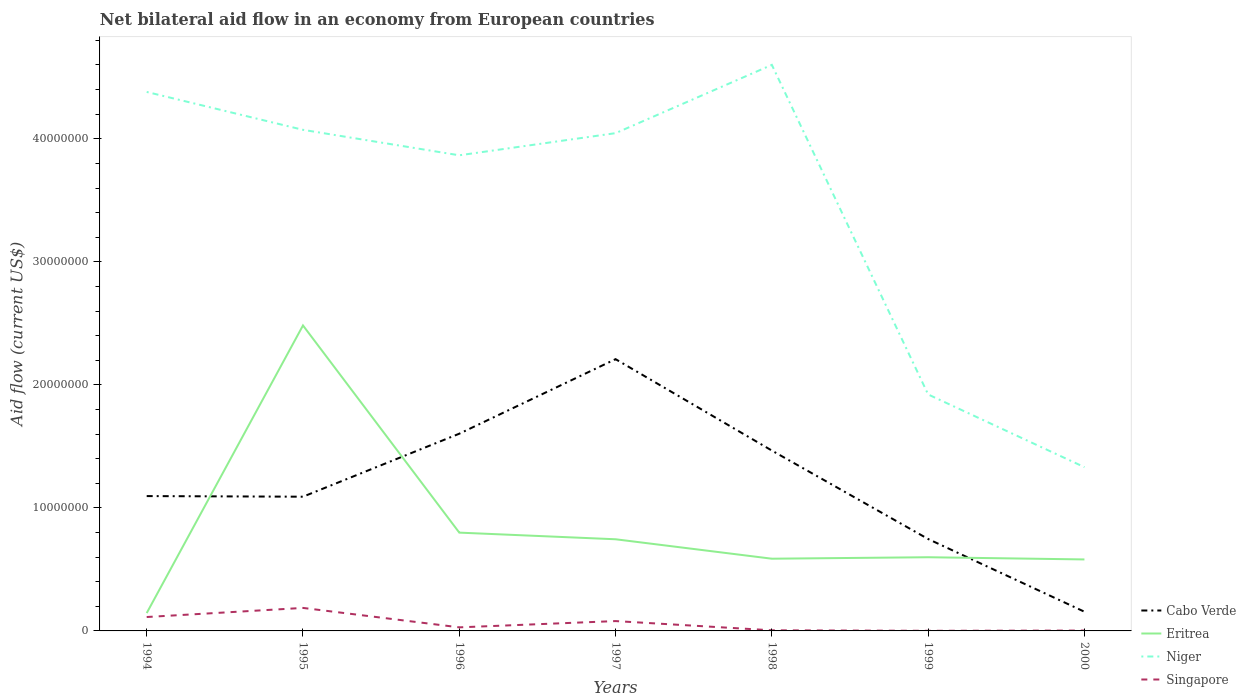Is the number of lines equal to the number of legend labels?
Offer a very short reply. Yes. Across all years, what is the maximum net bilateral aid flow in Eritrea?
Make the answer very short. 1.45e+06. What is the total net bilateral aid flow in Niger in the graph?
Give a very brief answer. 3.05e+07. What is the difference between the highest and the second highest net bilateral aid flow in Niger?
Give a very brief answer. 3.27e+07. How many lines are there?
Keep it short and to the point. 4. Are the values on the major ticks of Y-axis written in scientific E-notation?
Your answer should be compact. No. Does the graph contain any zero values?
Ensure brevity in your answer.  No. Where does the legend appear in the graph?
Make the answer very short. Bottom right. What is the title of the graph?
Provide a succinct answer. Net bilateral aid flow in an economy from European countries. Does "Marshall Islands" appear as one of the legend labels in the graph?
Offer a very short reply. No. What is the label or title of the X-axis?
Your response must be concise. Years. What is the label or title of the Y-axis?
Your answer should be compact. Aid flow (current US$). What is the Aid flow (current US$) of Cabo Verde in 1994?
Provide a short and direct response. 1.10e+07. What is the Aid flow (current US$) of Eritrea in 1994?
Your response must be concise. 1.45e+06. What is the Aid flow (current US$) in Niger in 1994?
Provide a short and direct response. 4.38e+07. What is the Aid flow (current US$) of Singapore in 1994?
Provide a short and direct response. 1.13e+06. What is the Aid flow (current US$) of Cabo Verde in 1995?
Ensure brevity in your answer.  1.09e+07. What is the Aid flow (current US$) of Eritrea in 1995?
Offer a very short reply. 2.48e+07. What is the Aid flow (current US$) in Niger in 1995?
Offer a very short reply. 4.07e+07. What is the Aid flow (current US$) of Singapore in 1995?
Your response must be concise. 1.87e+06. What is the Aid flow (current US$) of Cabo Verde in 1996?
Your answer should be compact. 1.60e+07. What is the Aid flow (current US$) of Eritrea in 1996?
Provide a succinct answer. 7.99e+06. What is the Aid flow (current US$) in Niger in 1996?
Ensure brevity in your answer.  3.87e+07. What is the Aid flow (current US$) in Cabo Verde in 1997?
Your answer should be very brief. 2.21e+07. What is the Aid flow (current US$) in Eritrea in 1997?
Provide a succinct answer. 7.45e+06. What is the Aid flow (current US$) of Niger in 1997?
Offer a terse response. 4.05e+07. What is the Aid flow (current US$) in Cabo Verde in 1998?
Provide a succinct answer. 1.47e+07. What is the Aid flow (current US$) in Eritrea in 1998?
Offer a very short reply. 5.87e+06. What is the Aid flow (current US$) of Niger in 1998?
Provide a short and direct response. 4.60e+07. What is the Aid flow (current US$) in Singapore in 1998?
Give a very brief answer. 5.00e+04. What is the Aid flow (current US$) of Cabo Verde in 1999?
Provide a short and direct response. 7.47e+06. What is the Aid flow (current US$) in Eritrea in 1999?
Ensure brevity in your answer.  5.99e+06. What is the Aid flow (current US$) in Niger in 1999?
Provide a short and direct response. 1.92e+07. What is the Aid flow (current US$) in Cabo Verde in 2000?
Give a very brief answer. 1.56e+06. What is the Aid flow (current US$) of Eritrea in 2000?
Your answer should be compact. 5.81e+06. What is the Aid flow (current US$) in Niger in 2000?
Offer a terse response. 1.33e+07. What is the Aid flow (current US$) of Singapore in 2000?
Ensure brevity in your answer.  3.00e+04. Across all years, what is the maximum Aid flow (current US$) in Cabo Verde?
Offer a terse response. 2.21e+07. Across all years, what is the maximum Aid flow (current US$) of Eritrea?
Your answer should be very brief. 2.48e+07. Across all years, what is the maximum Aid flow (current US$) in Niger?
Your response must be concise. 4.60e+07. Across all years, what is the maximum Aid flow (current US$) in Singapore?
Offer a terse response. 1.87e+06. Across all years, what is the minimum Aid flow (current US$) of Cabo Verde?
Your response must be concise. 1.56e+06. Across all years, what is the minimum Aid flow (current US$) of Eritrea?
Make the answer very short. 1.45e+06. Across all years, what is the minimum Aid flow (current US$) of Niger?
Give a very brief answer. 1.33e+07. Across all years, what is the minimum Aid flow (current US$) of Singapore?
Your response must be concise. 10000. What is the total Aid flow (current US$) in Cabo Verde in the graph?
Your answer should be very brief. 8.37e+07. What is the total Aid flow (current US$) of Eritrea in the graph?
Offer a very short reply. 5.94e+07. What is the total Aid flow (current US$) of Niger in the graph?
Make the answer very short. 2.42e+08. What is the total Aid flow (current US$) of Singapore in the graph?
Give a very brief answer. 4.18e+06. What is the difference between the Aid flow (current US$) of Cabo Verde in 1994 and that in 1995?
Your answer should be very brief. 5.00e+04. What is the difference between the Aid flow (current US$) in Eritrea in 1994 and that in 1995?
Offer a very short reply. -2.34e+07. What is the difference between the Aid flow (current US$) of Niger in 1994 and that in 1995?
Ensure brevity in your answer.  3.08e+06. What is the difference between the Aid flow (current US$) in Singapore in 1994 and that in 1995?
Ensure brevity in your answer.  -7.40e+05. What is the difference between the Aid flow (current US$) of Cabo Verde in 1994 and that in 1996?
Your answer should be compact. -5.07e+06. What is the difference between the Aid flow (current US$) of Eritrea in 1994 and that in 1996?
Your answer should be very brief. -6.54e+06. What is the difference between the Aid flow (current US$) of Niger in 1994 and that in 1996?
Your answer should be very brief. 5.15e+06. What is the difference between the Aid flow (current US$) in Singapore in 1994 and that in 1996?
Provide a short and direct response. 8.40e+05. What is the difference between the Aid flow (current US$) in Cabo Verde in 1994 and that in 1997?
Make the answer very short. -1.11e+07. What is the difference between the Aid flow (current US$) of Eritrea in 1994 and that in 1997?
Your response must be concise. -6.00e+06. What is the difference between the Aid flow (current US$) in Niger in 1994 and that in 1997?
Provide a succinct answer. 3.35e+06. What is the difference between the Aid flow (current US$) in Cabo Verde in 1994 and that in 1998?
Your answer should be compact. -3.70e+06. What is the difference between the Aid flow (current US$) in Eritrea in 1994 and that in 1998?
Offer a terse response. -4.42e+06. What is the difference between the Aid flow (current US$) in Niger in 1994 and that in 1998?
Your answer should be compact. -2.20e+06. What is the difference between the Aid flow (current US$) of Singapore in 1994 and that in 1998?
Offer a terse response. 1.08e+06. What is the difference between the Aid flow (current US$) of Cabo Verde in 1994 and that in 1999?
Offer a very short reply. 3.49e+06. What is the difference between the Aid flow (current US$) in Eritrea in 1994 and that in 1999?
Make the answer very short. -4.54e+06. What is the difference between the Aid flow (current US$) of Niger in 1994 and that in 1999?
Ensure brevity in your answer.  2.46e+07. What is the difference between the Aid flow (current US$) of Singapore in 1994 and that in 1999?
Give a very brief answer. 1.12e+06. What is the difference between the Aid flow (current US$) of Cabo Verde in 1994 and that in 2000?
Your answer should be very brief. 9.40e+06. What is the difference between the Aid flow (current US$) in Eritrea in 1994 and that in 2000?
Make the answer very short. -4.36e+06. What is the difference between the Aid flow (current US$) of Niger in 1994 and that in 2000?
Your answer should be compact. 3.05e+07. What is the difference between the Aid flow (current US$) in Singapore in 1994 and that in 2000?
Your answer should be very brief. 1.10e+06. What is the difference between the Aid flow (current US$) of Cabo Verde in 1995 and that in 1996?
Offer a very short reply. -5.12e+06. What is the difference between the Aid flow (current US$) in Eritrea in 1995 and that in 1996?
Ensure brevity in your answer.  1.68e+07. What is the difference between the Aid flow (current US$) of Niger in 1995 and that in 1996?
Keep it short and to the point. 2.07e+06. What is the difference between the Aid flow (current US$) of Singapore in 1995 and that in 1996?
Offer a terse response. 1.58e+06. What is the difference between the Aid flow (current US$) in Cabo Verde in 1995 and that in 1997?
Offer a very short reply. -1.12e+07. What is the difference between the Aid flow (current US$) of Eritrea in 1995 and that in 1997?
Offer a very short reply. 1.74e+07. What is the difference between the Aid flow (current US$) in Singapore in 1995 and that in 1997?
Offer a terse response. 1.07e+06. What is the difference between the Aid flow (current US$) of Cabo Verde in 1995 and that in 1998?
Offer a terse response. -3.75e+06. What is the difference between the Aid flow (current US$) in Eritrea in 1995 and that in 1998?
Keep it short and to the point. 1.90e+07. What is the difference between the Aid flow (current US$) of Niger in 1995 and that in 1998?
Offer a very short reply. -5.28e+06. What is the difference between the Aid flow (current US$) of Singapore in 1995 and that in 1998?
Keep it short and to the point. 1.82e+06. What is the difference between the Aid flow (current US$) in Cabo Verde in 1995 and that in 1999?
Offer a terse response. 3.44e+06. What is the difference between the Aid flow (current US$) of Eritrea in 1995 and that in 1999?
Make the answer very short. 1.88e+07. What is the difference between the Aid flow (current US$) of Niger in 1995 and that in 1999?
Your response must be concise. 2.15e+07. What is the difference between the Aid flow (current US$) of Singapore in 1995 and that in 1999?
Make the answer very short. 1.86e+06. What is the difference between the Aid flow (current US$) in Cabo Verde in 1995 and that in 2000?
Provide a short and direct response. 9.35e+06. What is the difference between the Aid flow (current US$) in Eritrea in 1995 and that in 2000?
Provide a short and direct response. 1.90e+07. What is the difference between the Aid flow (current US$) in Niger in 1995 and that in 2000?
Your response must be concise. 2.74e+07. What is the difference between the Aid flow (current US$) in Singapore in 1995 and that in 2000?
Provide a short and direct response. 1.84e+06. What is the difference between the Aid flow (current US$) in Cabo Verde in 1996 and that in 1997?
Your answer should be compact. -6.06e+06. What is the difference between the Aid flow (current US$) in Eritrea in 1996 and that in 1997?
Make the answer very short. 5.40e+05. What is the difference between the Aid flow (current US$) of Niger in 1996 and that in 1997?
Your answer should be compact. -1.80e+06. What is the difference between the Aid flow (current US$) of Singapore in 1996 and that in 1997?
Your answer should be compact. -5.10e+05. What is the difference between the Aid flow (current US$) in Cabo Verde in 1996 and that in 1998?
Keep it short and to the point. 1.37e+06. What is the difference between the Aid flow (current US$) in Eritrea in 1996 and that in 1998?
Keep it short and to the point. 2.12e+06. What is the difference between the Aid flow (current US$) in Niger in 1996 and that in 1998?
Give a very brief answer. -7.35e+06. What is the difference between the Aid flow (current US$) in Cabo Verde in 1996 and that in 1999?
Keep it short and to the point. 8.56e+06. What is the difference between the Aid flow (current US$) of Niger in 1996 and that in 1999?
Keep it short and to the point. 1.94e+07. What is the difference between the Aid flow (current US$) of Cabo Verde in 1996 and that in 2000?
Ensure brevity in your answer.  1.45e+07. What is the difference between the Aid flow (current US$) of Eritrea in 1996 and that in 2000?
Provide a short and direct response. 2.18e+06. What is the difference between the Aid flow (current US$) of Niger in 1996 and that in 2000?
Your response must be concise. 2.54e+07. What is the difference between the Aid flow (current US$) of Cabo Verde in 1997 and that in 1998?
Provide a short and direct response. 7.43e+06. What is the difference between the Aid flow (current US$) in Eritrea in 1997 and that in 1998?
Provide a short and direct response. 1.58e+06. What is the difference between the Aid flow (current US$) in Niger in 1997 and that in 1998?
Provide a succinct answer. -5.55e+06. What is the difference between the Aid flow (current US$) in Singapore in 1997 and that in 1998?
Your response must be concise. 7.50e+05. What is the difference between the Aid flow (current US$) in Cabo Verde in 1997 and that in 1999?
Keep it short and to the point. 1.46e+07. What is the difference between the Aid flow (current US$) of Eritrea in 1997 and that in 1999?
Provide a short and direct response. 1.46e+06. What is the difference between the Aid flow (current US$) of Niger in 1997 and that in 1999?
Ensure brevity in your answer.  2.12e+07. What is the difference between the Aid flow (current US$) of Singapore in 1997 and that in 1999?
Give a very brief answer. 7.90e+05. What is the difference between the Aid flow (current US$) of Cabo Verde in 1997 and that in 2000?
Your answer should be very brief. 2.05e+07. What is the difference between the Aid flow (current US$) in Eritrea in 1997 and that in 2000?
Keep it short and to the point. 1.64e+06. What is the difference between the Aid flow (current US$) in Niger in 1997 and that in 2000?
Keep it short and to the point. 2.72e+07. What is the difference between the Aid flow (current US$) of Singapore in 1997 and that in 2000?
Your response must be concise. 7.70e+05. What is the difference between the Aid flow (current US$) in Cabo Verde in 1998 and that in 1999?
Your response must be concise. 7.19e+06. What is the difference between the Aid flow (current US$) in Eritrea in 1998 and that in 1999?
Offer a terse response. -1.20e+05. What is the difference between the Aid flow (current US$) in Niger in 1998 and that in 1999?
Keep it short and to the point. 2.68e+07. What is the difference between the Aid flow (current US$) of Cabo Verde in 1998 and that in 2000?
Make the answer very short. 1.31e+07. What is the difference between the Aid flow (current US$) of Eritrea in 1998 and that in 2000?
Offer a terse response. 6.00e+04. What is the difference between the Aid flow (current US$) of Niger in 1998 and that in 2000?
Offer a very short reply. 3.27e+07. What is the difference between the Aid flow (current US$) in Cabo Verde in 1999 and that in 2000?
Provide a short and direct response. 5.91e+06. What is the difference between the Aid flow (current US$) of Eritrea in 1999 and that in 2000?
Keep it short and to the point. 1.80e+05. What is the difference between the Aid flow (current US$) of Niger in 1999 and that in 2000?
Your answer should be very brief. 5.91e+06. What is the difference between the Aid flow (current US$) of Cabo Verde in 1994 and the Aid flow (current US$) of Eritrea in 1995?
Your response must be concise. -1.39e+07. What is the difference between the Aid flow (current US$) of Cabo Verde in 1994 and the Aid flow (current US$) of Niger in 1995?
Give a very brief answer. -2.98e+07. What is the difference between the Aid flow (current US$) of Cabo Verde in 1994 and the Aid flow (current US$) of Singapore in 1995?
Keep it short and to the point. 9.09e+06. What is the difference between the Aid flow (current US$) in Eritrea in 1994 and the Aid flow (current US$) in Niger in 1995?
Offer a terse response. -3.93e+07. What is the difference between the Aid flow (current US$) in Eritrea in 1994 and the Aid flow (current US$) in Singapore in 1995?
Give a very brief answer. -4.20e+05. What is the difference between the Aid flow (current US$) in Niger in 1994 and the Aid flow (current US$) in Singapore in 1995?
Offer a terse response. 4.19e+07. What is the difference between the Aid flow (current US$) of Cabo Verde in 1994 and the Aid flow (current US$) of Eritrea in 1996?
Your response must be concise. 2.97e+06. What is the difference between the Aid flow (current US$) of Cabo Verde in 1994 and the Aid flow (current US$) of Niger in 1996?
Provide a succinct answer. -2.77e+07. What is the difference between the Aid flow (current US$) of Cabo Verde in 1994 and the Aid flow (current US$) of Singapore in 1996?
Your answer should be compact. 1.07e+07. What is the difference between the Aid flow (current US$) of Eritrea in 1994 and the Aid flow (current US$) of Niger in 1996?
Keep it short and to the point. -3.72e+07. What is the difference between the Aid flow (current US$) in Eritrea in 1994 and the Aid flow (current US$) in Singapore in 1996?
Provide a succinct answer. 1.16e+06. What is the difference between the Aid flow (current US$) in Niger in 1994 and the Aid flow (current US$) in Singapore in 1996?
Offer a very short reply. 4.35e+07. What is the difference between the Aid flow (current US$) of Cabo Verde in 1994 and the Aid flow (current US$) of Eritrea in 1997?
Your response must be concise. 3.51e+06. What is the difference between the Aid flow (current US$) of Cabo Verde in 1994 and the Aid flow (current US$) of Niger in 1997?
Your answer should be very brief. -2.95e+07. What is the difference between the Aid flow (current US$) in Cabo Verde in 1994 and the Aid flow (current US$) in Singapore in 1997?
Offer a terse response. 1.02e+07. What is the difference between the Aid flow (current US$) of Eritrea in 1994 and the Aid flow (current US$) of Niger in 1997?
Give a very brief answer. -3.90e+07. What is the difference between the Aid flow (current US$) of Eritrea in 1994 and the Aid flow (current US$) of Singapore in 1997?
Give a very brief answer. 6.50e+05. What is the difference between the Aid flow (current US$) of Niger in 1994 and the Aid flow (current US$) of Singapore in 1997?
Provide a succinct answer. 4.30e+07. What is the difference between the Aid flow (current US$) of Cabo Verde in 1994 and the Aid flow (current US$) of Eritrea in 1998?
Provide a succinct answer. 5.09e+06. What is the difference between the Aid flow (current US$) in Cabo Verde in 1994 and the Aid flow (current US$) in Niger in 1998?
Keep it short and to the point. -3.50e+07. What is the difference between the Aid flow (current US$) of Cabo Verde in 1994 and the Aid flow (current US$) of Singapore in 1998?
Offer a terse response. 1.09e+07. What is the difference between the Aid flow (current US$) of Eritrea in 1994 and the Aid flow (current US$) of Niger in 1998?
Your response must be concise. -4.46e+07. What is the difference between the Aid flow (current US$) in Eritrea in 1994 and the Aid flow (current US$) in Singapore in 1998?
Provide a short and direct response. 1.40e+06. What is the difference between the Aid flow (current US$) of Niger in 1994 and the Aid flow (current US$) of Singapore in 1998?
Make the answer very short. 4.38e+07. What is the difference between the Aid flow (current US$) in Cabo Verde in 1994 and the Aid flow (current US$) in Eritrea in 1999?
Offer a very short reply. 4.97e+06. What is the difference between the Aid flow (current US$) of Cabo Verde in 1994 and the Aid flow (current US$) of Niger in 1999?
Keep it short and to the point. -8.26e+06. What is the difference between the Aid flow (current US$) in Cabo Verde in 1994 and the Aid flow (current US$) in Singapore in 1999?
Offer a terse response. 1.10e+07. What is the difference between the Aid flow (current US$) of Eritrea in 1994 and the Aid flow (current US$) of Niger in 1999?
Your answer should be very brief. -1.78e+07. What is the difference between the Aid flow (current US$) of Eritrea in 1994 and the Aid flow (current US$) of Singapore in 1999?
Give a very brief answer. 1.44e+06. What is the difference between the Aid flow (current US$) of Niger in 1994 and the Aid flow (current US$) of Singapore in 1999?
Provide a succinct answer. 4.38e+07. What is the difference between the Aid flow (current US$) in Cabo Verde in 1994 and the Aid flow (current US$) in Eritrea in 2000?
Keep it short and to the point. 5.15e+06. What is the difference between the Aid flow (current US$) in Cabo Verde in 1994 and the Aid flow (current US$) in Niger in 2000?
Your answer should be very brief. -2.35e+06. What is the difference between the Aid flow (current US$) of Cabo Verde in 1994 and the Aid flow (current US$) of Singapore in 2000?
Offer a terse response. 1.09e+07. What is the difference between the Aid flow (current US$) of Eritrea in 1994 and the Aid flow (current US$) of Niger in 2000?
Provide a succinct answer. -1.19e+07. What is the difference between the Aid flow (current US$) of Eritrea in 1994 and the Aid flow (current US$) of Singapore in 2000?
Offer a terse response. 1.42e+06. What is the difference between the Aid flow (current US$) of Niger in 1994 and the Aid flow (current US$) of Singapore in 2000?
Keep it short and to the point. 4.38e+07. What is the difference between the Aid flow (current US$) of Cabo Verde in 1995 and the Aid flow (current US$) of Eritrea in 1996?
Offer a very short reply. 2.92e+06. What is the difference between the Aid flow (current US$) in Cabo Verde in 1995 and the Aid flow (current US$) in Niger in 1996?
Provide a succinct answer. -2.78e+07. What is the difference between the Aid flow (current US$) of Cabo Verde in 1995 and the Aid flow (current US$) of Singapore in 1996?
Your response must be concise. 1.06e+07. What is the difference between the Aid flow (current US$) of Eritrea in 1995 and the Aid flow (current US$) of Niger in 1996?
Ensure brevity in your answer.  -1.38e+07. What is the difference between the Aid flow (current US$) of Eritrea in 1995 and the Aid flow (current US$) of Singapore in 1996?
Offer a very short reply. 2.45e+07. What is the difference between the Aid flow (current US$) of Niger in 1995 and the Aid flow (current US$) of Singapore in 1996?
Keep it short and to the point. 4.04e+07. What is the difference between the Aid flow (current US$) of Cabo Verde in 1995 and the Aid flow (current US$) of Eritrea in 1997?
Your response must be concise. 3.46e+06. What is the difference between the Aid flow (current US$) in Cabo Verde in 1995 and the Aid flow (current US$) in Niger in 1997?
Provide a succinct answer. -2.96e+07. What is the difference between the Aid flow (current US$) in Cabo Verde in 1995 and the Aid flow (current US$) in Singapore in 1997?
Offer a terse response. 1.01e+07. What is the difference between the Aid flow (current US$) in Eritrea in 1995 and the Aid flow (current US$) in Niger in 1997?
Offer a very short reply. -1.56e+07. What is the difference between the Aid flow (current US$) of Eritrea in 1995 and the Aid flow (current US$) of Singapore in 1997?
Offer a terse response. 2.40e+07. What is the difference between the Aid flow (current US$) of Niger in 1995 and the Aid flow (current US$) of Singapore in 1997?
Provide a succinct answer. 3.99e+07. What is the difference between the Aid flow (current US$) in Cabo Verde in 1995 and the Aid flow (current US$) in Eritrea in 1998?
Offer a very short reply. 5.04e+06. What is the difference between the Aid flow (current US$) of Cabo Verde in 1995 and the Aid flow (current US$) of Niger in 1998?
Keep it short and to the point. -3.51e+07. What is the difference between the Aid flow (current US$) in Cabo Verde in 1995 and the Aid flow (current US$) in Singapore in 1998?
Ensure brevity in your answer.  1.09e+07. What is the difference between the Aid flow (current US$) in Eritrea in 1995 and the Aid flow (current US$) in Niger in 1998?
Offer a very short reply. -2.12e+07. What is the difference between the Aid flow (current US$) in Eritrea in 1995 and the Aid flow (current US$) in Singapore in 1998?
Provide a succinct answer. 2.48e+07. What is the difference between the Aid flow (current US$) in Niger in 1995 and the Aid flow (current US$) in Singapore in 1998?
Your answer should be compact. 4.07e+07. What is the difference between the Aid flow (current US$) of Cabo Verde in 1995 and the Aid flow (current US$) of Eritrea in 1999?
Provide a short and direct response. 4.92e+06. What is the difference between the Aid flow (current US$) of Cabo Verde in 1995 and the Aid flow (current US$) of Niger in 1999?
Offer a very short reply. -8.31e+06. What is the difference between the Aid flow (current US$) of Cabo Verde in 1995 and the Aid flow (current US$) of Singapore in 1999?
Your answer should be compact. 1.09e+07. What is the difference between the Aid flow (current US$) of Eritrea in 1995 and the Aid flow (current US$) of Niger in 1999?
Provide a short and direct response. 5.61e+06. What is the difference between the Aid flow (current US$) of Eritrea in 1995 and the Aid flow (current US$) of Singapore in 1999?
Give a very brief answer. 2.48e+07. What is the difference between the Aid flow (current US$) of Niger in 1995 and the Aid flow (current US$) of Singapore in 1999?
Offer a terse response. 4.07e+07. What is the difference between the Aid flow (current US$) in Cabo Verde in 1995 and the Aid flow (current US$) in Eritrea in 2000?
Your answer should be very brief. 5.10e+06. What is the difference between the Aid flow (current US$) in Cabo Verde in 1995 and the Aid flow (current US$) in Niger in 2000?
Offer a terse response. -2.40e+06. What is the difference between the Aid flow (current US$) of Cabo Verde in 1995 and the Aid flow (current US$) of Singapore in 2000?
Provide a short and direct response. 1.09e+07. What is the difference between the Aid flow (current US$) of Eritrea in 1995 and the Aid flow (current US$) of Niger in 2000?
Offer a very short reply. 1.15e+07. What is the difference between the Aid flow (current US$) of Eritrea in 1995 and the Aid flow (current US$) of Singapore in 2000?
Keep it short and to the point. 2.48e+07. What is the difference between the Aid flow (current US$) in Niger in 1995 and the Aid flow (current US$) in Singapore in 2000?
Give a very brief answer. 4.07e+07. What is the difference between the Aid flow (current US$) of Cabo Verde in 1996 and the Aid flow (current US$) of Eritrea in 1997?
Your response must be concise. 8.58e+06. What is the difference between the Aid flow (current US$) in Cabo Verde in 1996 and the Aid flow (current US$) in Niger in 1997?
Ensure brevity in your answer.  -2.44e+07. What is the difference between the Aid flow (current US$) in Cabo Verde in 1996 and the Aid flow (current US$) in Singapore in 1997?
Your answer should be very brief. 1.52e+07. What is the difference between the Aid flow (current US$) of Eritrea in 1996 and the Aid flow (current US$) of Niger in 1997?
Offer a very short reply. -3.25e+07. What is the difference between the Aid flow (current US$) of Eritrea in 1996 and the Aid flow (current US$) of Singapore in 1997?
Keep it short and to the point. 7.19e+06. What is the difference between the Aid flow (current US$) in Niger in 1996 and the Aid flow (current US$) in Singapore in 1997?
Give a very brief answer. 3.79e+07. What is the difference between the Aid flow (current US$) of Cabo Verde in 1996 and the Aid flow (current US$) of Eritrea in 1998?
Provide a succinct answer. 1.02e+07. What is the difference between the Aid flow (current US$) of Cabo Verde in 1996 and the Aid flow (current US$) of Niger in 1998?
Give a very brief answer. -3.00e+07. What is the difference between the Aid flow (current US$) of Cabo Verde in 1996 and the Aid flow (current US$) of Singapore in 1998?
Make the answer very short. 1.60e+07. What is the difference between the Aid flow (current US$) of Eritrea in 1996 and the Aid flow (current US$) of Niger in 1998?
Your answer should be very brief. -3.80e+07. What is the difference between the Aid flow (current US$) in Eritrea in 1996 and the Aid flow (current US$) in Singapore in 1998?
Your answer should be very brief. 7.94e+06. What is the difference between the Aid flow (current US$) of Niger in 1996 and the Aid flow (current US$) of Singapore in 1998?
Offer a very short reply. 3.86e+07. What is the difference between the Aid flow (current US$) of Cabo Verde in 1996 and the Aid flow (current US$) of Eritrea in 1999?
Give a very brief answer. 1.00e+07. What is the difference between the Aid flow (current US$) of Cabo Verde in 1996 and the Aid flow (current US$) of Niger in 1999?
Provide a short and direct response. -3.19e+06. What is the difference between the Aid flow (current US$) of Cabo Verde in 1996 and the Aid flow (current US$) of Singapore in 1999?
Make the answer very short. 1.60e+07. What is the difference between the Aid flow (current US$) in Eritrea in 1996 and the Aid flow (current US$) in Niger in 1999?
Make the answer very short. -1.12e+07. What is the difference between the Aid flow (current US$) in Eritrea in 1996 and the Aid flow (current US$) in Singapore in 1999?
Provide a succinct answer. 7.98e+06. What is the difference between the Aid flow (current US$) of Niger in 1996 and the Aid flow (current US$) of Singapore in 1999?
Your answer should be very brief. 3.86e+07. What is the difference between the Aid flow (current US$) in Cabo Verde in 1996 and the Aid flow (current US$) in Eritrea in 2000?
Your answer should be very brief. 1.02e+07. What is the difference between the Aid flow (current US$) in Cabo Verde in 1996 and the Aid flow (current US$) in Niger in 2000?
Provide a succinct answer. 2.72e+06. What is the difference between the Aid flow (current US$) in Cabo Verde in 1996 and the Aid flow (current US$) in Singapore in 2000?
Ensure brevity in your answer.  1.60e+07. What is the difference between the Aid flow (current US$) of Eritrea in 1996 and the Aid flow (current US$) of Niger in 2000?
Ensure brevity in your answer.  -5.32e+06. What is the difference between the Aid flow (current US$) in Eritrea in 1996 and the Aid flow (current US$) in Singapore in 2000?
Your response must be concise. 7.96e+06. What is the difference between the Aid flow (current US$) of Niger in 1996 and the Aid flow (current US$) of Singapore in 2000?
Ensure brevity in your answer.  3.86e+07. What is the difference between the Aid flow (current US$) of Cabo Verde in 1997 and the Aid flow (current US$) of Eritrea in 1998?
Your answer should be compact. 1.62e+07. What is the difference between the Aid flow (current US$) in Cabo Verde in 1997 and the Aid flow (current US$) in Niger in 1998?
Keep it short and to the point. -2.39e+07. What is the difference between the Aid flow (current US$) of Cabo Verde in 1997 and the Aid flow (current US$) of Singapore in 1998?
Your answer should be compact. 2.20e+07. What is the difference between the Aid flow (current US$) of Eritrea in 1997 and the Aid flow (current US$) of Niger in 1998?
Provide a short and direct response. -3.86e+07. What is the difference between the Aid flow (current US$) of Eritrea in 1997 and the Aid flow (current US$) of Singapore in 1998?
Offer a very short reply. 7.40e+06. What is the difference between the Aid flow (current US$) in Niger in 1997 and the Aid flow (current US$) in Singapore in 1998?
Keep it short and to the point. 4.04e+07. What is the difference between the Aid flow (current US$) in Cabo Verde in 1997 and the Aid flow (current US$) in Eritrea in 1999?
Your response must be concise. 1.61e+07. What is the difference between the Aid flow (current US$) of Cabo Verde in 1997 and the Aid flow (current US$) of Niger in 1999?
Your answer should be very brief. 2.87e+06. What is the difference between the Aid flow (current US$) of Cabo Verde in 1997 and the Aid flow (current US$) of Singapore in 1999?
Offer a very short reply. 2.21e+07. What is the difference between the Aid flow (current US$) of Eritrea in 1997 and the Aid flow (current US$) of Niger in 1999?
Offer a very short reply. -1.18e+07. What is the difference between the Aid flow (current US$) in Eritrea in 1997 and the Aid flow (current US$) in Singapore in 1999?
Make the answer very short. 7.44e+06. What is the difference between the Aid flow (current US$) of Niger in 1997 and the Aid flow (current US$) of Singapore in 1999?
Your answer should be very brief. 4.04e+07. What is the difference between the Aid flow (current US$) in Cabo Verde in 1997 and the Aid flow (current US$) in Eritrea in 2000?
Offer a terse response. 1.63e+07. What is the difference between the Aid flow (current US$) in Cabo Verde in 1997 and the Aid flow (current US$) in Niger in 2000?
Provide a succinct answer. 8.78e+06. What is the difference between the Aid flow (current US$) in Cabo Verde in 1997 and the Aid flow (current US$) in Singapore in 2000?
Ensure brevity in your answer.  2.21e+07. What is the difference between the Aid flow (current US$) of Eritrea in 1997 and the Aid flow (current US$) of Niger in 2000?
Provide a succinct answer. -5.86e+06. What is the difference between the Aid flow (current US$) in Eritrea in 1997 and the Aid flow (current US$) in Singapore in 2000?
Give a very brief answer. 7.42e+06. What is the difference between the Aid flow (current US$) in Niger in 1997 and the Aid flow (current US$) in Singapore in 2000?
Ensure brevity in your answer.  4.04e+07. What is the difference between the Aid flow (current US$) in Cabo Verde in 1998 and the Aid flow (current US$) in Eritrea in 1999?
Keep it short and to the point. 8.67e+06. What is the difference between the Aid flow (current US$) in Cabo Verde in 1998 and the Aid flow (current US$) in Niger in 1999?
Make the answer very short. -4.56e+06. What is the difference between the Aid flow (current US$) of Cabo Verde in 1998 and the Aid flow (current US$) of Singapore in 1999?
Provide a succinct answer. 1.46e+07. What is the difference between the Aid flow (current US$) of Eritrea in 1998 and the Aid flow (current US$) of Niger in 1999?
Offer a terse response. -1.34e+07. What is the difference between the Aid flow (current US$) of Eritrea in 1998 and the Aid flow (current US$) of Singapore in 1999?
Your answer should be compact. 5.86e+06. What is the difference between the Aid flow (current US$) in Niger in 1998 and the Aid flow (current US$) in Singapore in 1999?
Your answer should be very brief. 4.60e+07. What is the difference between the Aid flow (current US$) of Cabo Verde in 1998 and the Aid flow (current US$) of Eritrea in 2000?
Your answer should be compact. 8.85e+06. What is the difference between the Aid flow (current US$) in Cabo Verde in 1998 and the Aid flow (current US$) in Niger in 2000?
Your answer should be very brief. 1.35e+06. What is the difference between the Aid flow (current US$) of Cabo Verde in 1998 and the Aid flow (current US$) of Singapore in 2000?
Your response must be concise. 1.46e+07. What is the difference between the Aid flow (current US$) of Eritrea in 1998 and the Aid flow (current US$) of Niger in 2000?
Make the answer very short. -7.44e+06. What is the difference between the Aid flow (current US$) in Eritrea in 1998 and the Aid flow (current US$) in Singapore in 2000?
Make the answer very short. 5.84e+06. What is the difference between the Aid flow (current US$) of Niger in 1998 and the Aid flow (current US$) of Singapore in 2000?
Provide a short and direct response. 4.60e+07. What is the difference between the Aid flow (current US$) of Cabo Verde in 1999 and the Aid flow (current US$) of Eritrea in 2000?
Your answer should be compact. 1.66e+06. What is the difference between the Aid flow (current US$) of Cabo Verde in 1999 and the Aid flow (current US$) of Niger in 2000?
Your answer should be compact. -5.84e+06. What is the difference between the Aid flow (current US$) in Cabo Verde in 1999 and the Aid flow (current US$) in Singapore in 2000?
Provide a succinct answer. 7.44e+06. What is the difference between the Aid flow (current US$) of Eritrea in 1999 and the Aid flow (current US$) of Niger in 2000?
Give a very brief answer. -7.32e+06. What is the difference between the Aid flow (current US$) in Eritrea in 1999 and the Aid flow (current US$) in Singapore in 2000?
Provide a short and direct response. 5.96e+06. What is the difference between the Aid flow (current US$) of Niger in 1999 and the Aid flow (current US$) of Singapore in 2000?
Give a very brief answer. 1.92e+07. What is the average Aid flow (current US$) in Cabo Verde per year?
Your answer should be very brief. 1.20e+07. What is the average Aid flow (current US$) in Eritrea per year?
Your response must be concise. 8.48e+06. What is the average Aid flow (current US$) in Niger per year?
Your answer should be compact. 3.46e+07. What is the average Aid flow (current US$) in Singapore per year?
Give a very brief answer. 5.97e+05. In the year 1994, what is the difference between the Aid flow (current US$) of Cabo Verde and Aid flow (current US$) of Eritrea?
Provide a short and direct response. 9.51e+06. In the year 1994, what is the difference between the Aid flow (current US$) of Cabo Verde and Aid flow (current US$) of Niger?
Make the answer very short. -3.28e+07. In the year 1994, what is the difference between the Aid flow (current US$) in Cabo Verde and Aid flow (current US$) in Singapore?
Make the answer very short. 9.83e+06. In the year 1994, what is the difference between the Aid flow (current US$) of Eritrea and Aid flow (current US$) of Niger?
Your answer should be compact. -4.24e+07. In the year 1994, what is the difference between the Aid flow (current US$) in Niger and Aid flow (current US$) in Singapore?
Your response must be concise. 4.27e+07. In the year 1995, what is the difference between the Aid flow (current US$) in Cabo Verde and Aid flow (current US$) in Eritrea?
Provide a short and direct response. -1.39e+07. In the year 1995, what is the difference between the Aid flow (current US$) of Cabo Verde and Aid flow (current US$) of Niger?
Give a very brief answer. -2.98e+07. In the year 1995, what is the difference between the Aid flow (current US$) of Cabo Verde and Aid flow (current US$) of Singapore?
Give a very brief answer. 9.04e+06. In the year 1995, what is the difference between the Aid flow (current US$) in Eritrea and Aid flow (current US$) in Niger?
Provide a short and direct response. -1.59e+07. In the year 1995, what is the difference between the Aid flow (current US$) of Eritrea and Aid flow (current US$) of Singapore?
Your answer should be compact. 2.30e+07. In the year 1995, what is the difference between the Aid flow (current US$) of Niger and Aid flow (current US$) of Singapore?
Your answer should be compact. 3.89e+07. In the year 1996, what is the difference between the Aid flow (current US$) of Cabo Verde and Aid flow (current US$) of Eritrea?
Your answer should be compact. 8.04e+06. In the year 1996, what is the difference between the Aid flow (current US$) of Cabo Verde and Aid flow (current US$) of Niger?
Ensure brevity in your answer.  -2.26e+07. In the year 1996, what is the difference between the Aid flow (current US$) in Cabo Verde and Aid flow (current US$) in Singapore?
Make the answer very short. 1.57e+07. In the year 1996, what is the difference between the Aid flow (current US$) in Eritrea and Aid flow (current US$) in Niger?
Keep it short and to the point. -3.07e+07. In the year 1996, what is the difference between the Aid flow (current US$) of Eritrea and Aid flow (current US$) of Singapore?
Ensure brevity in your answer.  7.70e+06. In the year 1996, what is the difference between the Aid flow (current US$) in Niger and Aid flow (current US$) in Singapore?
Your response must be concise. 3.84e+07. In the year 1997, what is the difference between the Aid flow (current US$) in Cabo Verde and Aid flow (current US$) in Eritrea?
Ensure brevity in your answer.  1.46e+07. In the year 1997, what is the difference between the Aid flow (current US$) of Cabo Verde and Aid flow (current US$) of Niger?
Provide a short and direct response. -1.84e+07. In the year 1997, what is the difference between the Aid flow (current US$) in Cabo Verde and Aid flow (current US$) in Singapore?
Your response must be concise. 2.13e+07. In the year 1997, what is the difference between the Aid flow (current US$) in Eritrea and Aid flow (current US$) in Niger?
Give a very brief answer. -3.30e+07. In the year 1997, what is the difference between the Aid flow (current US$) of Eritrea and Aid flow (current US$) of Singapore?
Your response must be concise. 6.65e+06. In the year 1997, what is the difference between the Aid flow (current US$) of Niger and Aid flow (current US$) of Singapore?
Give a very brief answer. 3.97e+07. In the year 1998, what is the difference between the Aid flow (current US$) of Cabo Verde and Aid flow (current US$) of Eritrea?
Your answer should be compact. 8.79e+06. In the year 1998, what is the difference between the Aid flow (current US$) in Cabo Verde and Aid flow (current US$) in Niger?
Provide a short and direct response. -3.14e+07. In the year 1998, what is the difference between the Aid flow (current US$) of Cabo Verde and Aid flow (current US$) of Singapore?
Offer a very short reply. 1.46e+07. In the year 1998, what is the difference between the Aid flow (current US$) of Eritrea and Aid flow (current US$) of Niger?
Offer a very short reply. -4.01e+07. In the year 1998, what is the difference between the Aid flow (current US$) in Eritrea and Aid flow (current US$) in Singapore?
Give a very brief answer. 5.82e+06. In the year 1998, what is the difference between the Aid flow (current US$) of Niger and Aid flow (current US$) of Singapore?
Make the answer very short. 4.60e+07. In the year 1999, what is the difference between the Aid flow (current US$) in Cabo Verde and Aid flow (current US$) in Eritrea?
Make the answer very short. 1.48e+06. In the year 1999, what is the difference between the Aid flow (current US$) in Cabo Verde and Aid flow (current US$) in Niger?
Provide a succinct answer. -1.18e+07. In the year 1999, what is the difference between the Aid flow (current US$) in Cabo Verde and Aid flow (current US$) in Singapore?
Your response must be concise. 7.46e+06. In the year 1999, what is the difference between the Aid flow (current US$) of Eritrea and Aid flow (current US$) of Niger?
Give a very brief answer. -1.32e+07. In the year 1999, what is the difference between the Aid flow (current US$) in Eritrea and Aid flow (current US$) in Singapore?
Give a very brief answer. 5.98e+06. In the year 1999, what is the difference between the Aid flow (current US$) in Niger and Aid flow (current US$) in Singapore?
Offer a terse response. 1.92e+07. In the year 2000, what is the difference between the Aid flow (current US$) in Cabo Verde and Aid flow (current US$) in Eritrea?
Offer a terse response. -4.25e+06. In the year 2000, what is the difference between the Aid flow (current US$) of Cabo Verde and Aid flow (current US$) of Niger?
Offer a terse response. -1.18e+07. In the year 2000, what is the difference between the Aid flow (current US$) of Cabo Verde and Aid flow (current US$) of Singapore?
Offer a very short reply. 1.53e+06. In the year 2000, what is the difference between the Aid flow (current US$) of Eritrea and Aid flow (current US$) of Niger?
Provide a succinct answer. -7.50e+06. In the year 2000, what is the difference between the Aid flow (current US$) in Eritrea and Aid flow (current US$) in Singapore?
Offer a very short reply. 5.78e+06. In the year 2000, what is the difference between the Aid flow (current US$) of Niger and Aid flow (current US$) of Singapore?
Keep it short and to the point. 1.33e+07. What is the ratio of the Aid flow (current US$) of Cabo Verde in 1994 to that in 1995?
Provide a short and direct response. 1. What is the ratio of the Aid flow (current US$) in Eritrea in 1994 to that in 1995?
Offer a very short reply. 0.06. What is the ratio of the Aid flow (current US$) of Niger in 1994 to that in 1995?
Offer a very short reply. 1.08. What is the ratio of the Aid flow (current US$) in Singapore in 1994 to that in 1995?
Your answer should be compact. 0.6. What is the ratio of the Aid flow (current US$) in Cabo Verde in 1994 to that in 1996?
Keep it short and to the point. 0.68. What is the ratio of the Aid flow (current US$) in Eritrea in 1994 to that in 1996?
Your response must be concise. 0.18. What is the ratio of the Aid flow (current US$) of Niger in 1994 to that in 1996?
Make the answer very short. 1.13. What is the ratio of the Aid flow (current US$) in Singapore in 1994 to that in 1996?
Offer a very short reply. 3.9. What is the ratio of the Aid flow (current US$) in Cabo Verde in 1994 to that in 1997?
Make the answer very short. 0.5. What is the ratio of the Aid flow (current US$) in Eritrea in 1994 to that in 1997?
Offer a very short reply. 0.19. What is the ratio of the Aid flow (current US$) of Niger in 1994 to that in 1997?
Your answer should be compact. 1.08. What is the ratio of the Aid flow (current US$) in Singapore in 1994 to that in 1997?
Your answer should be very brief. 1.41. What is the ratio of the Aid flow (current US$) in Cabo Verde in 1994 to that in 1998?
Keep it short and to the point. 0.75. What is the ratio of the Aid flow (current US$) of Eritrea in 1994 to that in 1998?
Your answer should be compact. 0.25. What is the ratio of the Aid flow (current US$) in Niger in 1994 to that in 1998?
Offer a very short reply. 0.95. What is the ratio of the Aid flow (current US$) in Singapore in 1994 to that in 1998?
Make the answer very short. 22.6. What is the ratio of the Aid flow (current US$) of Cabo Verde in 1994 to that in 1999?
Ensure brevity in your answer.  1.47. What is the ratio of the Aid flow (current US$) of Eritrea in 1994 to that in 1999?
Your answer should be compact. 0.24. What is the ratio of the Aid flow (current US$) in Niger in 1994 to that in 1999?
Your response must be concise. 2.28. What is the ratio of the Aid flow (current US$) in Singapore in 1994 to that in 1999?
Provide a succinct answer. 113. What is the ratio of the Aid flow (current US$) of Cabo Verde in 1994 to that in 2000?
Provide a succinct answer. 7.03. What is the ratio of the Aid flow (current US$) in Eritrea in 1994 to that in 2000?
Provide a succinct answer. 0.25. What is the ratio of the Aid flow (current US$) of Niger in 1994 to that in 2000?
Your response must be concise. 3.29. What is the ratio of the Aid flow (current US$) in Singapore in 1994 to that in 2000?
Provide a short and direct response. 37.67. What is the ratio of the Aid flow (current US$) in Cabo Verde in 1995 to that in 1996?
Offer a terse response. 0.68. What is the ratio of the Aid flow (current US$) in Eritrea in 1995 to that in 1996?
Offer a terse response. 3.11. What is the ratio of the Aid flow (current US$) of Niger in 1995 to that in 1996?
Offer a terse response. 1.05. What is the ratio of the Aid flow (current US$) of Singapore in 1995 to that in 1996?
Keep it short and to the point. 6.45. What is the ratio of the Aid flow (current US$) of Cabo Verde in 1995 to that in 1997?
Give a very brief answer. 0.49. What is the ratio of the Aid flow (current US$) in Eritrea in 1995 to that in 1997?
Keep it short and to the point. 3.33. What is the ratio of the Aid flow (current US$) of Singapore in 1995 to that in 1997?
Your response must be concise. 2.34. What is the ratio of the Aid flow (current US$) in Cabo Verde in 1995 to that in 1998?
Offer a terse response. 0.74. What is the ratio of the Aid flow (current US$) in Eritrea in 1995 to that in 1998?
Offer a terse response. 4.23. What is the ratio of the Aid flow (current US$) of Niger in 1995 to that in 1998?
Keep it short and to the point. 0.89. What is the ratio of the Aid flow (current US$) in Singapore in 1995 to that in 1998?
Offer a very short reply. 37.4. What is the ratio of the Aid flow (current US$) of Cabo Verde in 1995 to that in 1999?
Provide a succinct answer. 1.46. What is the ratio of the Aid flow (current US$) of Eritrea in 1995 to that in 1999?
Provide a short and direct response. 4.15. What is the ratio of the Aid flow (current US$) in Niger in 1995 to that in 1999?
Give a very brief answer. 2.12. What is the ratio of the Aid flow (current US$) in Singapore in 1995 to that in 1999?
Provide a succinct answer. 187. What is the ratio of the Aid flow (current US$) of Cabo Verde in 1995 to that in 2000?
Provide a succinct answer. 6.99. What is the ratio of the Aid flow (current US$) of Eritrea in 1995 to that in 2000?
Make the answer very short. 4.27. What is the ratio of the Aid flow (current US$) in Niger in 1995 to that in 2000?
Your response must be concise. 3.06. What is the ratio of the Aid flow (current US$) in Singapore in 1995 to that in 2000?
Your answer should be very brief. 62.33. What is the ratio of the Aid flow (current US$) of Cabo Verde in 1996 to that in 1997?
Give a very brief answer. 0.73. What is the ratio of the Aid flow (current US$) of Eritrea in 1996 to that in 1997?
Give a very brief answer. 1.07. What is the ratio of the Aid flow (current US$) in Niger in 1996 to that in 1997?
Keep it short and to the point. 0.96. What is the ratio of the Aid flow (current US$) in Singapore in 1996 to that in 1997?
Give a very brief answer. 0.36. What is the ratio of the Aid flow (current US$) of Cabo Verde in 1996 to that in 1998?
Provide a short and direct response. 1.09. What is the ratio of the Aid flow (current US$) of Eritrea in 1996 to that in 1998?
Make the answer very short. 1.36. What is the ratio of the Aid flow (current US$) in Niger in 1996 to that in 1998?
Ensure brevity in your answer.  0.84. What is the ratio of the Aid flow (current US$) of Singapore in 1996 to that in 1998?
Provide a succinct answer. 5.8. What is the ratio of the Aid flow (current US$) in Cabo Verde in 1996 to that in 1999?
Offer a terse response. 2.15. What is the ratio of the Aid flow (current US$) of Eritrea in 1996 to that in 1999?
Provide a succinct answer. 1.33. What is the ratio of the Aid flow (current US$) of Niger in 1996 to that in 1999?
Keep it short and to the point. 2.01. What is the ratio of the Aid flow (current US$) of Singapore in 1996 to that in 1999?
Offer a terse response. 29. What is the ratio of the Aid flow (current US$) in Cabo Verde in 1996 to that in 2000?
Your answer should be compact. 10.28. What is the ratio of the Aid flow (current US$) of Eritrea in 1996 to that in 2000?
Give a very brief answer. 1.38. What is the ratio of the Aid flow (current US$) in Niger in 1996 to that in 2000?
Provide a short and direct response. 2.9. What is the ratio of the Aid flow (current US$) in Singapore in 1996 to that in 2000?
Your answer should be very brief. 9.67. What is the ratio of the Aid flow (current US$) in Cabo Verde in 1997 to that in 1998?
Ensure brevity in your answer.  1.51. What is the ratio of the Aid flow (current US$) of Eritrea in 1997 to that in 1998?
Give a very brief answer. 1.27. What is the ratio of the Aid flow (current US$) of Niger in 1997 to that in 1998?
Your response must be concise. 0.88. What is the ratio of the Aid flow (current US$) in Cabo Verde in 1997 to that in 1999?
Provide a short and direct response. 2.96. What is the ratio of the Aid flow (current US$) in Eritrea in 1997 to that in 1999?
Make the answer very short. 1.24. What is the ratio of the Aid flow (current US$) in Niger in 1997 to that in 1999?
Your response must be concise. 2.11. What is the ratio of the Aid flow (current US$) of Cabo Verde in 1997 to that in 2000?
Your answer should be very brief. 14.16. What is the ratio of the Aid flow (current US$) of Eritrea in 1997 to that in 2000?
Offer a terse response. 1.28. What is the ratio of the Aid flow (current US$) of Niger in 1997 to that in 2000?
Offer a very short reply. 3.04. What is the ratio of the Aid flow (current US$) of Singapore in 1997 to that in 2000?
Ensure brevity in your answer.  26.67. What is the ratio of the Aid flow (current US$) of Cabo Verde in 1998 to that in 1999?
Offer a terse response. 1.96. What is the ratio of the Aid flow (current US$) in Niger in 1998 to that in 1999?
Ensure brevity in your answer.  2.39. What is the ratio of the Aid flow (current US$) in Singapore in 1998 to that in 1999?
Keep it short and to the point. 5. What is the ratio of the Aid flow (current US$) in Cabo Verde in 1998 to that in 2000?
Your answer should be very brief. 9.4. What is the ratio of the Aid flow (current US$) of Eritrea in 1998 to that in 2000?
Ensure brevity in your answer.  1.01. What is the ratio of the Aid flow (current US$) in Niger in 1998 to that in 2000?
Your answer should be compact. 3.46. What is the ratio of the Aid flow (current US$) of Cabo Verde in 1999 to that in 2000?
Your answer should be very brief. 4.79. What is the ratio of the Aid flow (current US$) of Eritrea in 1999 to that in 2000?
Make the answer very short. 1.03. What is the ratio of the Aid flow (current US$) of Niger in 1999 to that in 2000?
Your answer should be compact. 1.44. What is the difference between the highest and the second highest Aid flow (current US$) in Cabo Verde?
Give a very brief answer. 6.06e+06. What is the difference between the highest and the second highest Aid flow (current US$) of Eritrea?
Offer a very short reply. 1.68e+07. What is the difference between the highest and the second highest Aid flow (current US$) of Niger?
Keep it short and to the point. 2.20e+06. What is the difference between the highest and the second highest Aid flow (current US$) in Singapore?
Your answer should be very brief. 7.40e+05. What is the difference between the highest and the lowest Aid flow (current US$) in Cabo Verde?
Offer a very short reply. 2.05e+07. What is the difference between the highest and the lowest Aid flow (current US$) in Eritrea?
Offer a very short reply. 2.34e+07. What is the difference between the highest and the lowest Aid flow (current US$) of Niger?
Your answer should be very brief. 3.27e+07. What is the difference between the highest and the lowest Aid flow (current US$) of Singapore?
Provide a succinct answer. 1.86e+06. 